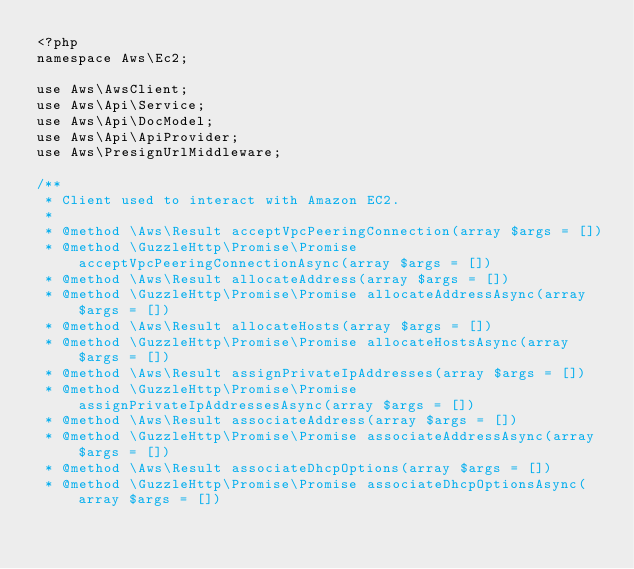<code> <loc_0><loc_0><loc_500><loc_500><_PHP_><?php
namespace Aws\Ec2;

use Aws\AwsClient;
use Aws\Api\Service;
use Aws\Api\DocModel;
use Aws\Api\ApiProvider;
use Aws\PresignUrlMiddleware;

/**
 * Client used to interact with Amazon EC2.
 *
 * @method \Aws\Result acceptVpcPeeringConnection(array $args = [])
 * @method \GuzzleHttp\Promise\Promise acceptVpcPeeringConnectionAsync(array $args = [])
 * @method \Aws\Result allocateAddress(array $args = [])
 * @method \GuzzleHttp\Promise\Promise allocateAddressAsync(array $args = [])
 * @method \Aws\Result allocateHosts(array $args = [])
 * @method \GuzzleHttp\Promise\Promise allocateHostsAsync(array $args = [])
 * @method \Aws\Result assignPrivateIpAddresses(array $args = [])
 * @method \GuzzleHttp\Promise\Promise assignPrivateIpAddressesAsync(array $args = [])
 * @method \Aws\Result associateAddress(array $args = [])
 * @method \GuzzleHttp\Promise\Promise associateAddressAsync(array $args = [])
 * @method \Aws\Result associateDhcpOptions(array $args = [])
 * @method \GuzzleHttp\Promise\Promise associateDhcpOptionsAsync(array $args = [])</code> 